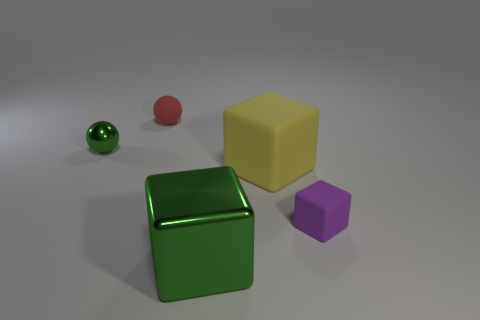There is another object that is the same shape as the tiny red matte object; what is its size?
Provide a succinct answer. Small. How many green balls are there?
Make the answer very short. 1. Is the shape of the purple rubber thing the same as the green shiny thing that is behind the small purple cube?
Provide a succinct answer. No. There is a rubber object that is behind the yellow rubber cube; what is its size?
Ensure brevity in your answer.  Small. What material is the tiny green ball?
Provide a succinct answer. Metal. Is the shape of the small rubber object that is left of the yellow object the same as  the large yellow object?
Offer a very short reply. No. There is a shiny ball that is the same color as the big metal thing; what is its size?
Give a very brief answer. Small. Are there any matte things of the same size as the green shiny cube?
Keep it short and to the point. Yes. There is a matte thing in front of the rubber block that is on the left side of the small purple rubber block; is there a tiny green metal sphere that is to the right of it?
Offer a terse response. No. There is a big shiny object; does it have the same color as the shiny object that is behind the purple thing?
Your answer should be very brief. Yes. 